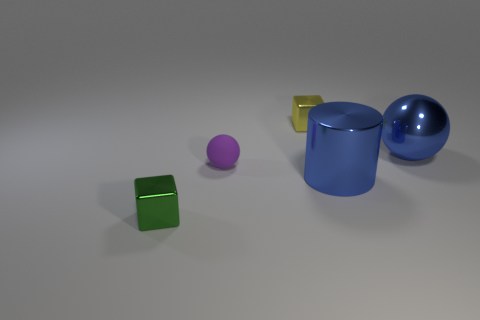Subtract all blue balls. How many balls are left? 1 Add 4 large spheres. How many objects exist? 9 Subtract 1 balls. How many balls are left? 1 Subtract all spheres. How many objects are left? 3 Add 5 small yellow objects. How many small yellow objects are left? 6 Add 5 spheres. How many spheres exist? 7 Subtract 0 gray blocks. How many objects are left? 5 Subtract all yellow blocks. Subtract all cyan spheres. How many blocks are left? 1 Subtract all purple cylinders. How many yellow blocks are left? 1 Subtract all small matte things. Subtract all purple spheres. How many objects are left? 3 